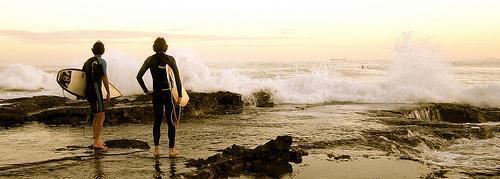How many men are in the photo?
Give a very brief answer. 2. 